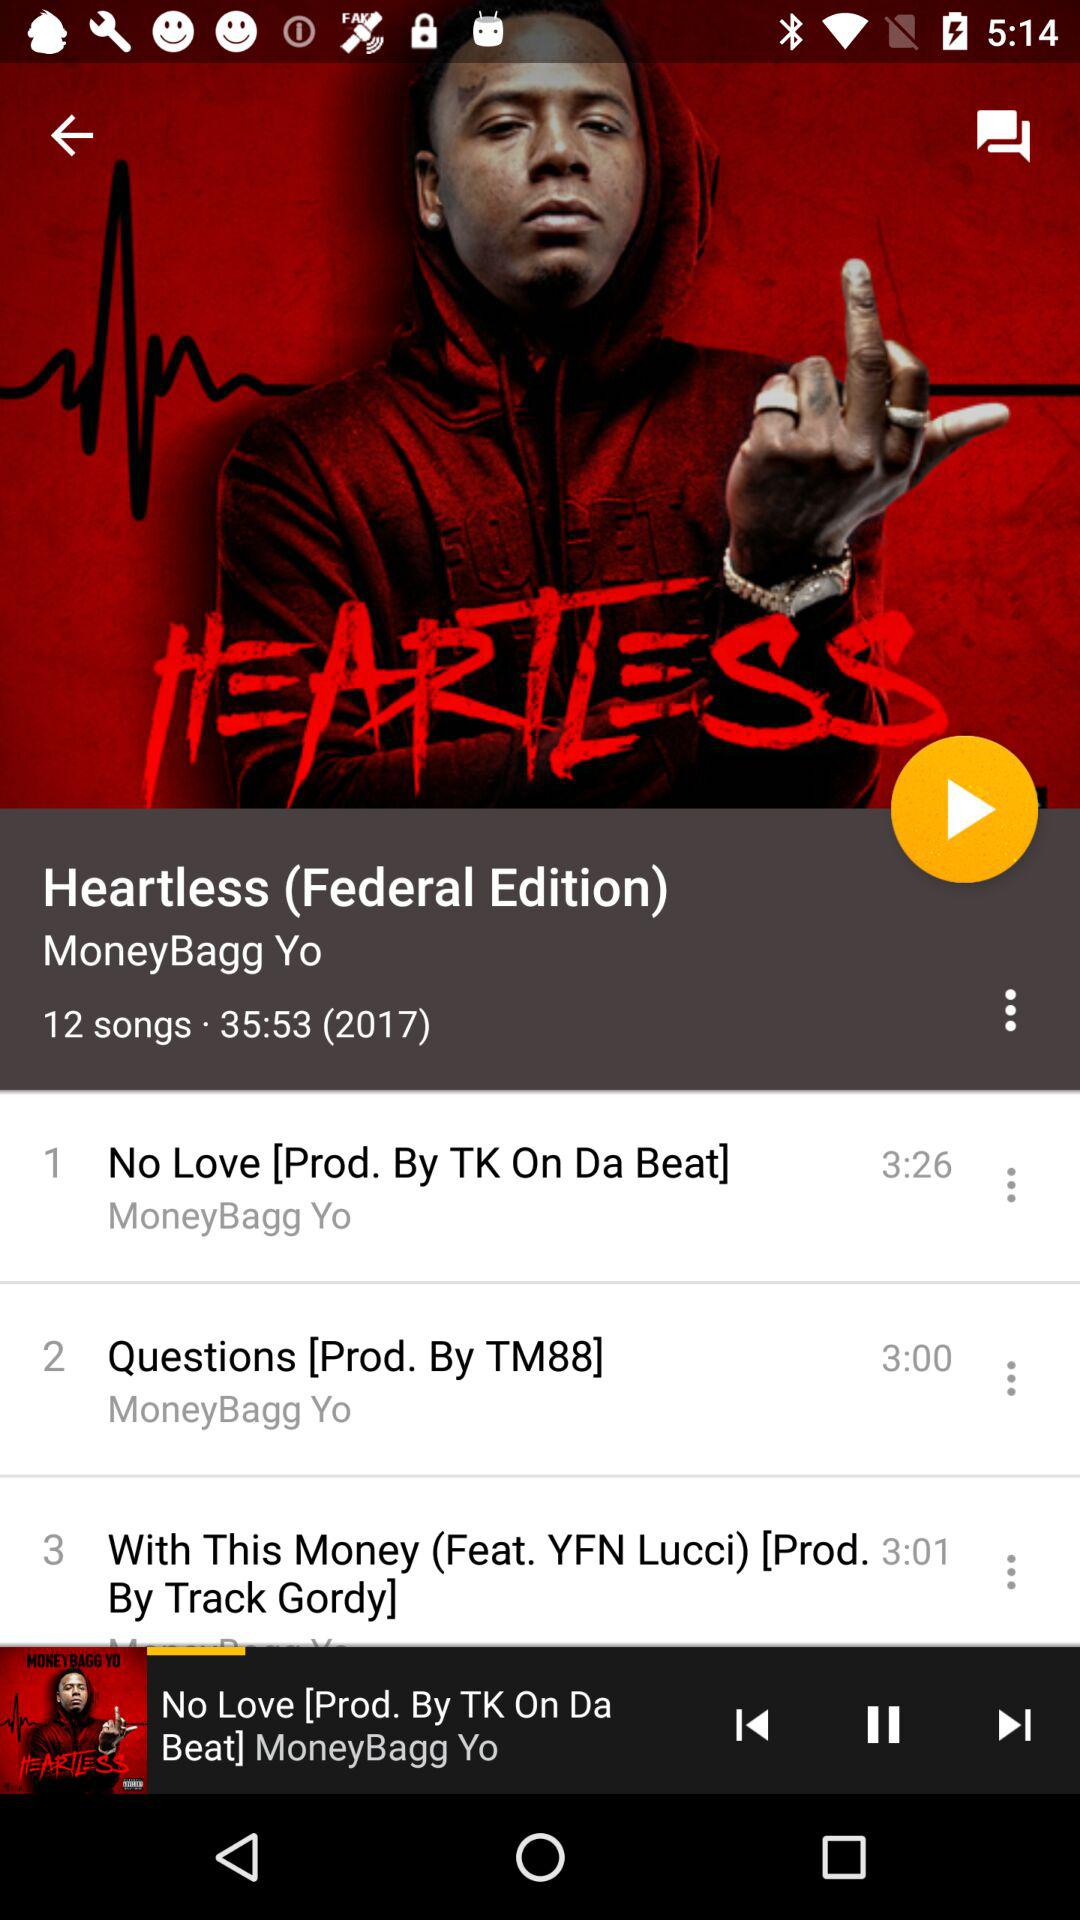What is the launch year of the album? The launch year of the album is 2017. 